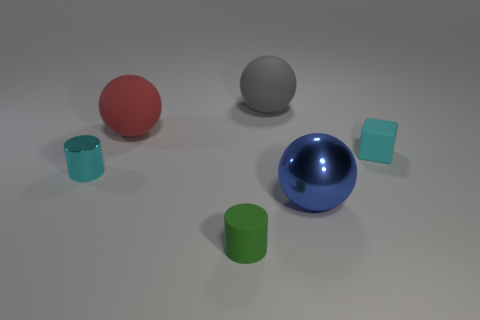What number of tiny rubber blocks are behind the tiny rubber object that is behind the blue shiny sphere right of the tiny cyan metal cylinder?
Keep it short and to the point. 0. What is the small object that is behind the tiny green cylinder and right of the tiny metallic thing made of?
Ensure brevity in your answer.  Rubber. Do the red object and the cylinder that is in front of the small cyan metallic object have the same material?
Ensure brevity in your answer.  Yes. Are there more large gray matte balls that are on the right side of the cyan cube than big blue shiny spheres that are left of the red matte ball?
Your answer should be compact. No. There is a red rubber thing; what shape is it?
Provide a short and direct response. Sphere. Is the big sphere in front of the cyan cube made of the same material as the tiny object in front of the small cyan metallic thing?
Your answer should be compact. No. The cyan thing that is to the left of the block has what shape?
Keep it short and to the point. Cylinder. There is a gray matte thing that is the same shape as the blue metal object; what is its size?
Your answer should be very brief. Large. Does the large metal sphere have the same color as the tiny matte cylinder?
Ensure brevity in your answer.  No. Are there any other things that have the same shape as the big gray thing?
Make the answer very short. Yes. 